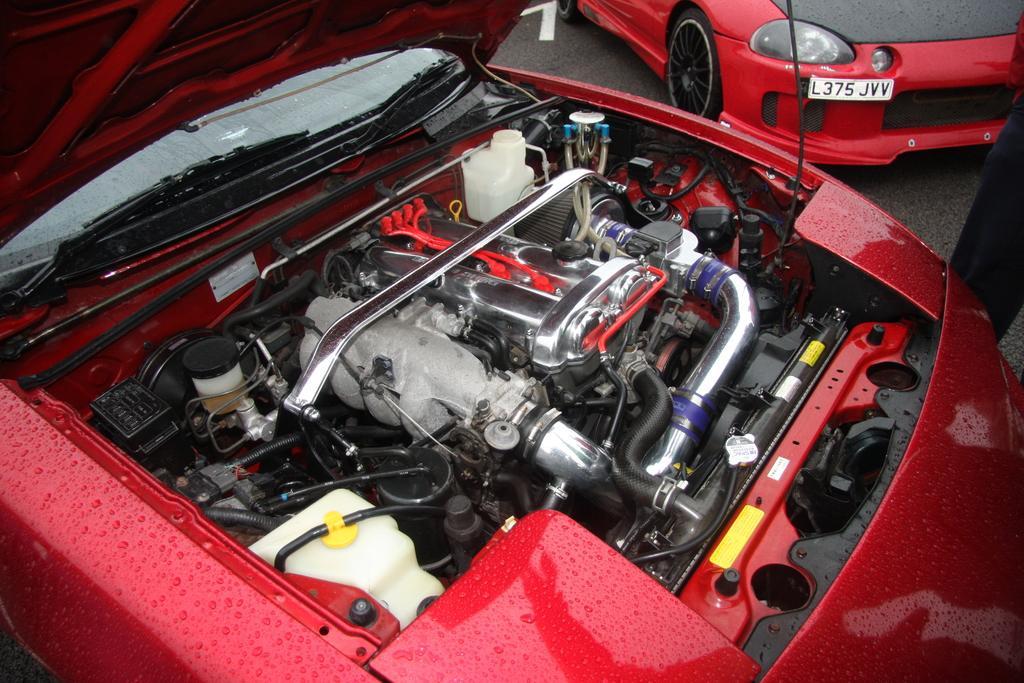In one or two sentences, can you explain what this image depicts? In this image I can see front of part of the car, on which there are cable wires, other objects, pipes visible, in the top right corner I can see another car, may be leg of person. 